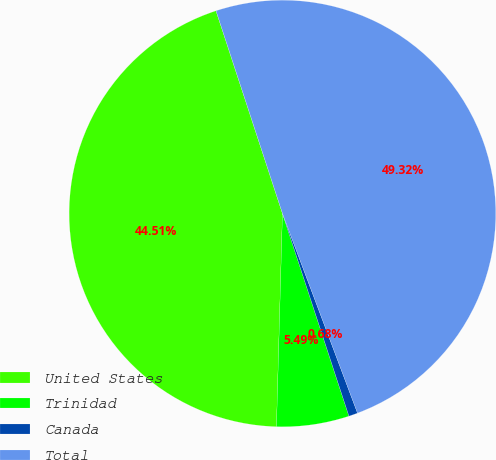<chart> <loc_0><loc_0><loc_500><loc_500><pie_chart><fcel>United States<fcel>Trinidad<fcel>Canada<fcel>Total<nl><fcel>44.51%<fcel>5.49%<fcel>0.68%<fcel>49.32%<nl></chart> 